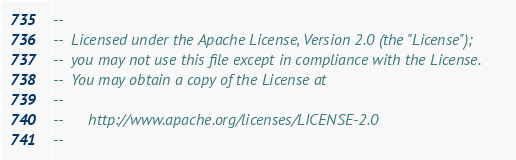<code> <loc_0><loc_0><loc_500><loc_500><_SQL_>--
--  Licensed under the Apache License, Version 2.0 (the "License");
--  you may not use this file except in compliance with the License.
--  You may obtain a copy of the License at
--
--      http://www.apache.org/licenses/LICENSE-2.0
--</code> 